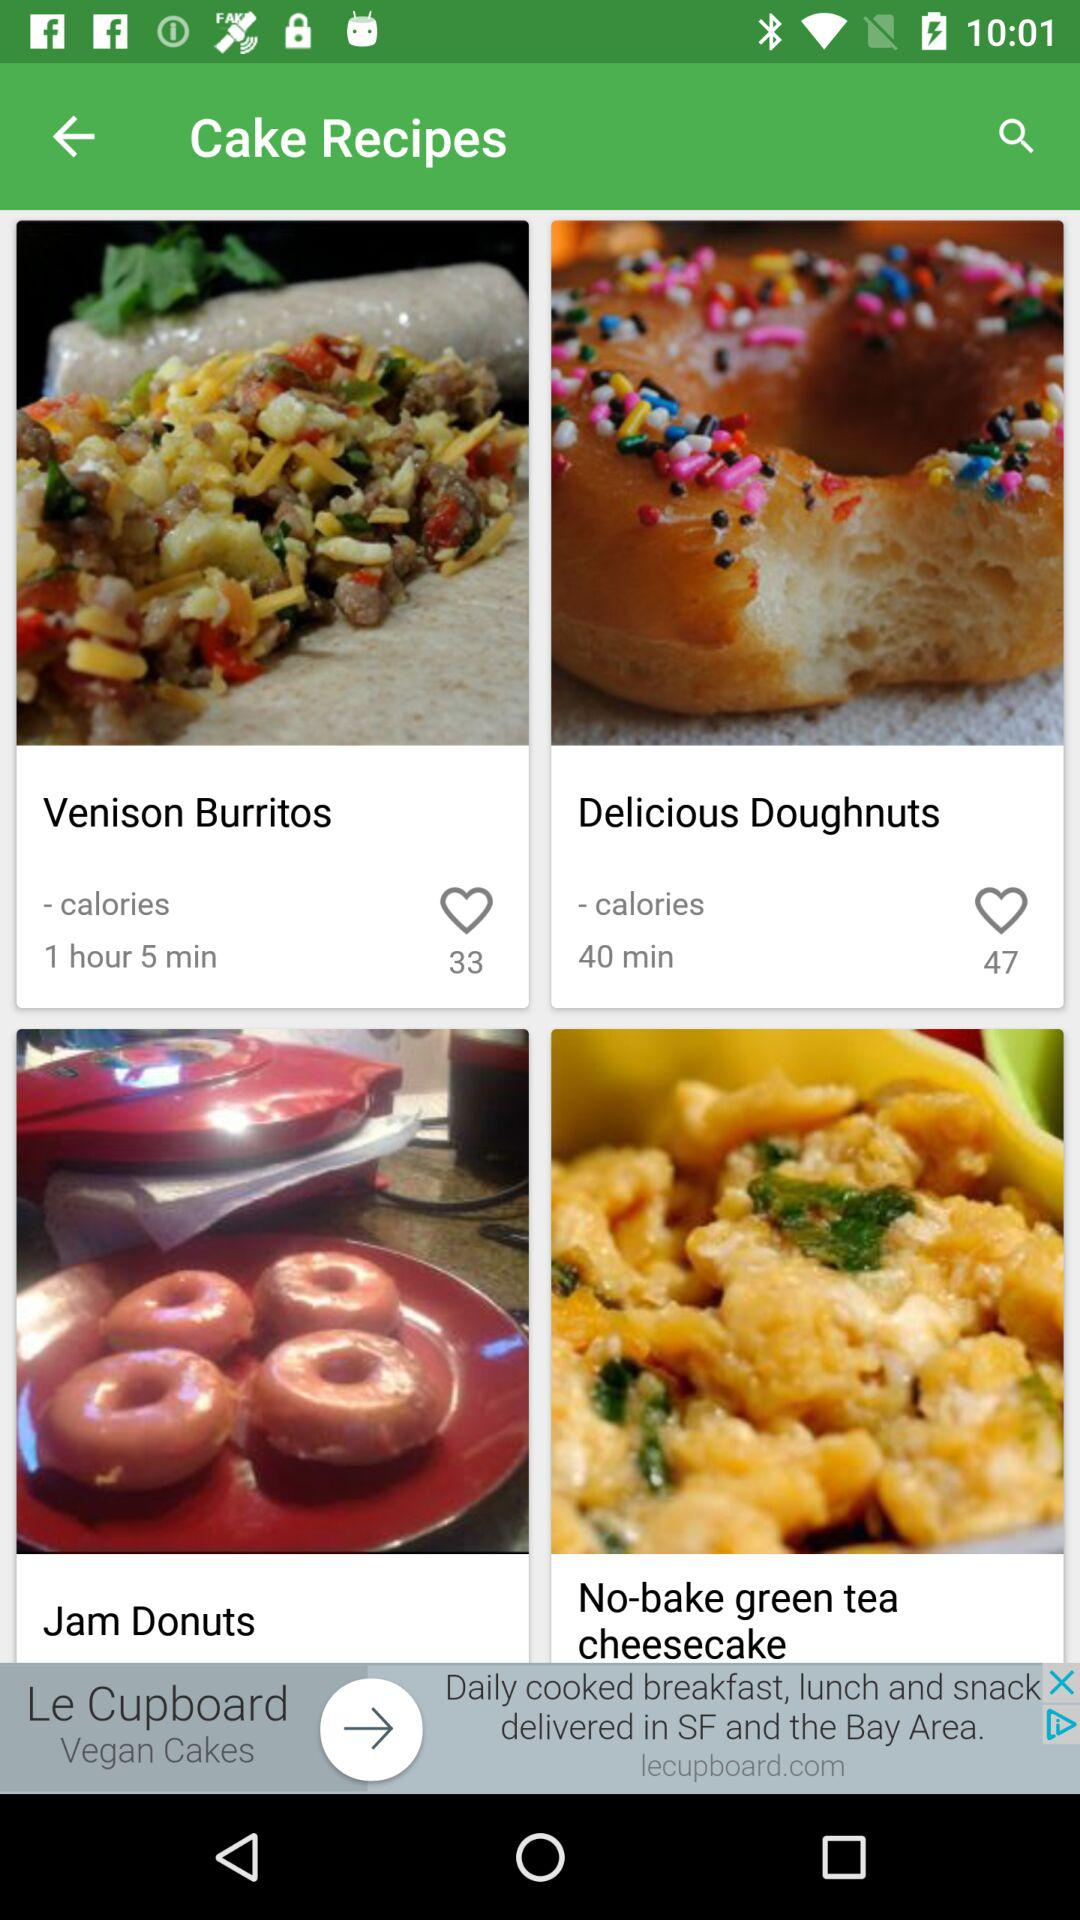How long will it take for the venison burritos to be ready? It will take 1 hour 5 minutes for the venison burritos to be ready. 